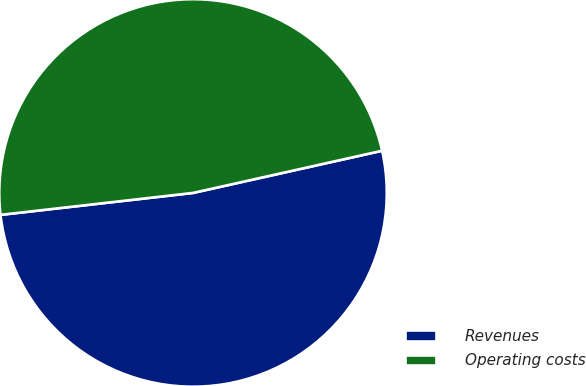Convert chart to OTSL. <chart><loc_0><loc_0><loc_500><loc_500><pie_chart><fcel>Revenues<fcel>Operating costs<nl><fcel>51.69%<fcel>48.31%<nl></chart> 